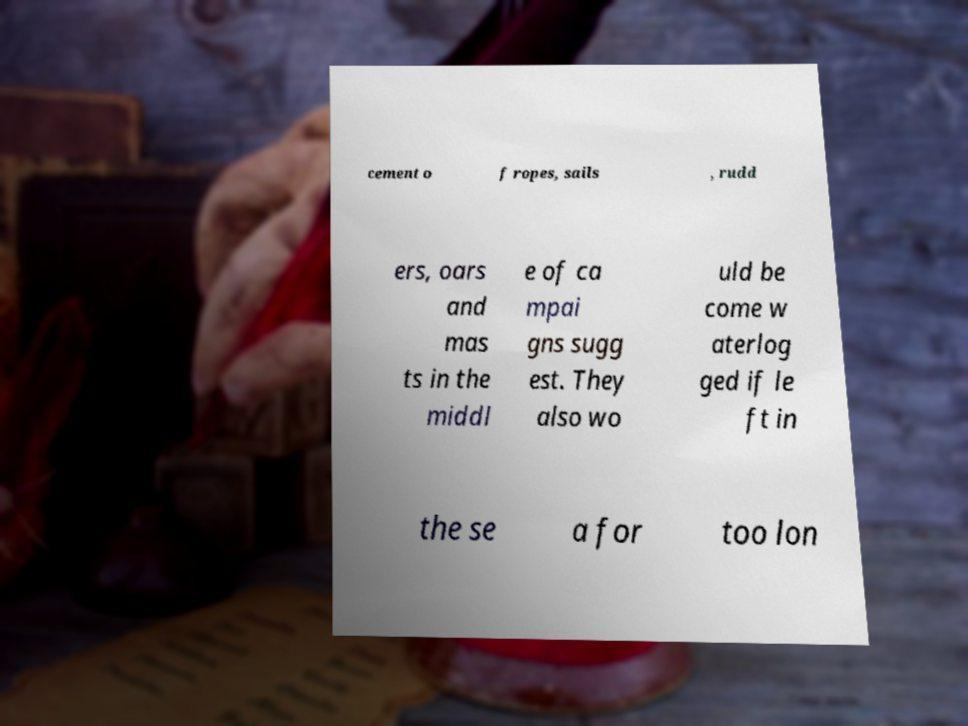Can you accurately transcribe the text from the provided image for me? cement o f ropes, sails , rudd ers, oars and mas ts in the middl e of ca mpai gns sugg est. They also wo uld be come w aterlog ged if le ft in the se a for too lon 